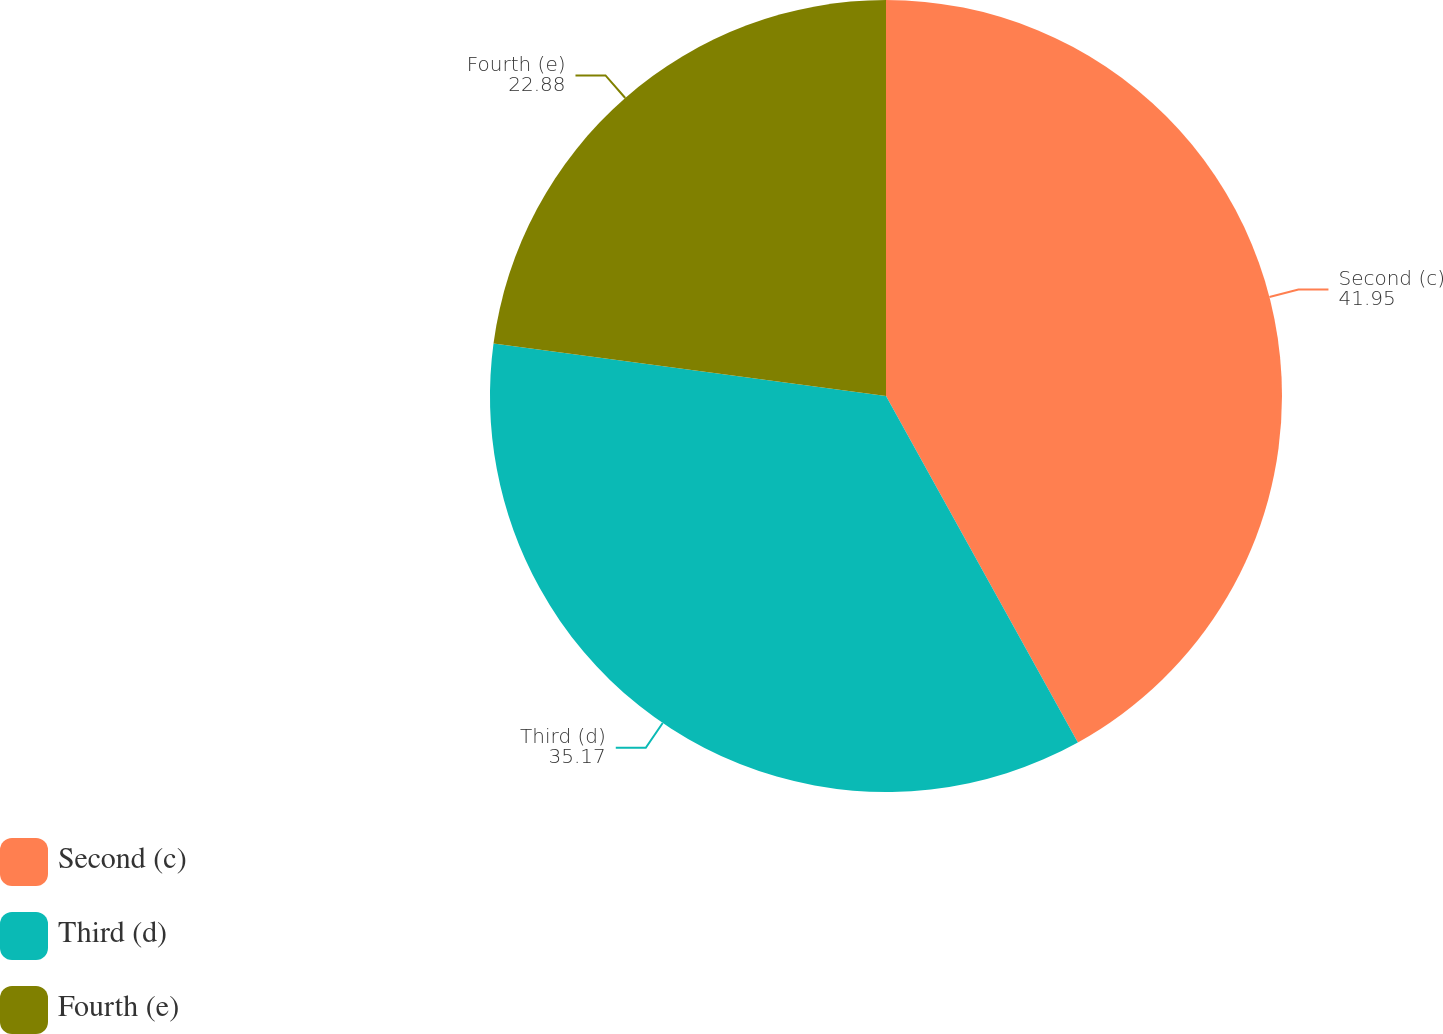<chart> <loc_0><loc_0><loc_500><loc_500><pie_chart><fcel>Second (c)<fcel>Third (d)<fcel>Fourth (e)<nl><fcel>41.95%<fcel>35.17%<fcel>22.88%<nl></chart> 